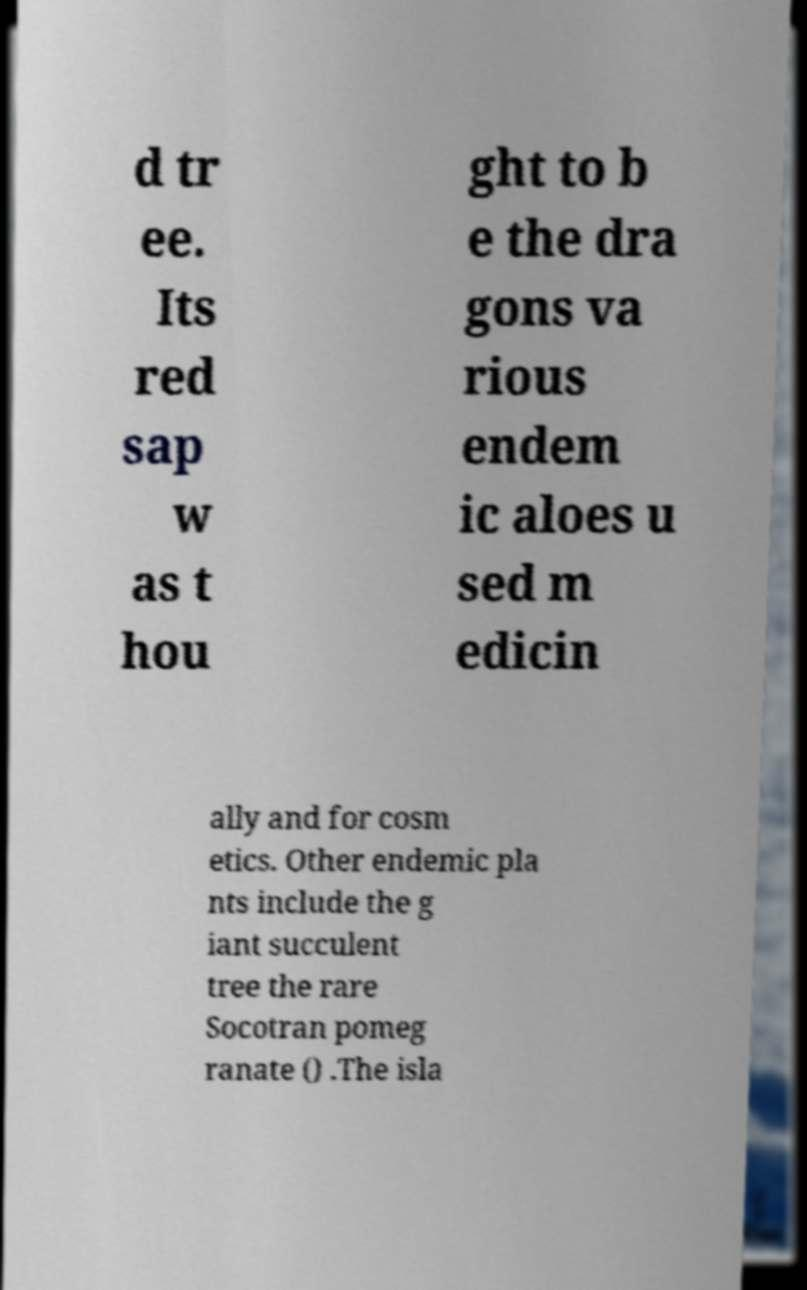For documentation purposes, I need the text within this image transcribed. Could you provide that? d tr ee. Its red sap w as t hou ght to b e the dra gons va rious endem ic aloes u sed m edicin ally and for cosm etics. Other endemic pla nts include the g iant succulent tree the rare Socotran pomeg ranate () .The isla 